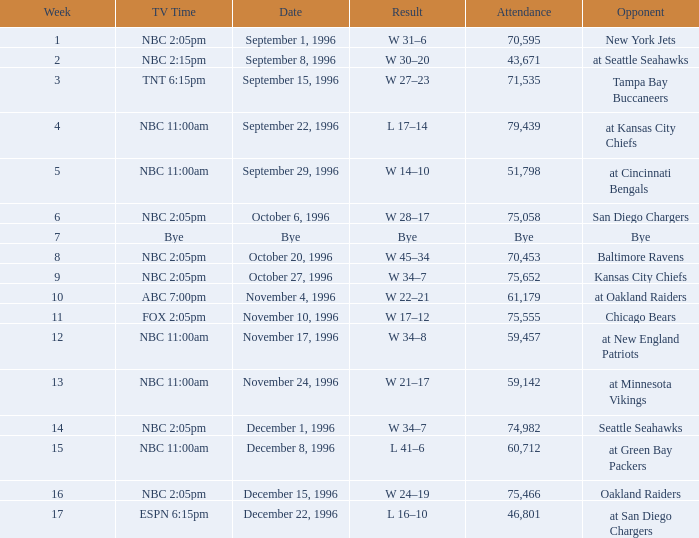WHAT IS THE TV TIME FOR NOVEMBER 10, 1996? FOX 2:05pm. 